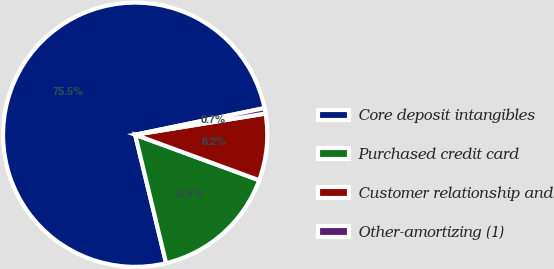<chart> <loc_0><loc_0><loc_500><loc_500><pie_chart><fcel>Core deposit intangibles<fcel>Purchased credit card<fcel>Customer relationship and<fcel>Other-amortizing (1)<nl><fcel>75.53%<fcel>15.64%<fcel>8.16%<fcel>0.67%<nl></chart> 